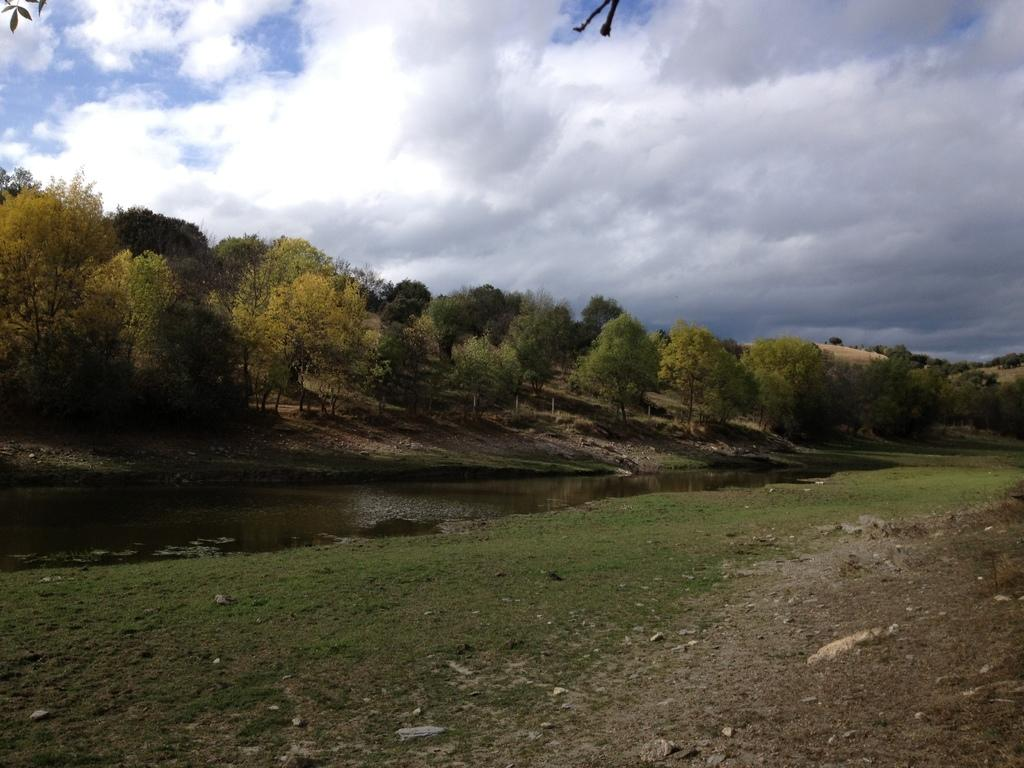What type of vegetation is present in the image? There is grass in the image. What else can be seen in the image besides grass? There is water and trees in the image. What is visible in the background of the image? The sky is visible in the background of the image. Can you see a nut on the crown of the tree in the image? There is no nut or crown visible on the trees in the image. Is there a cook preparing a meal in the image? There is no cook or meal preparation visible in the image. 